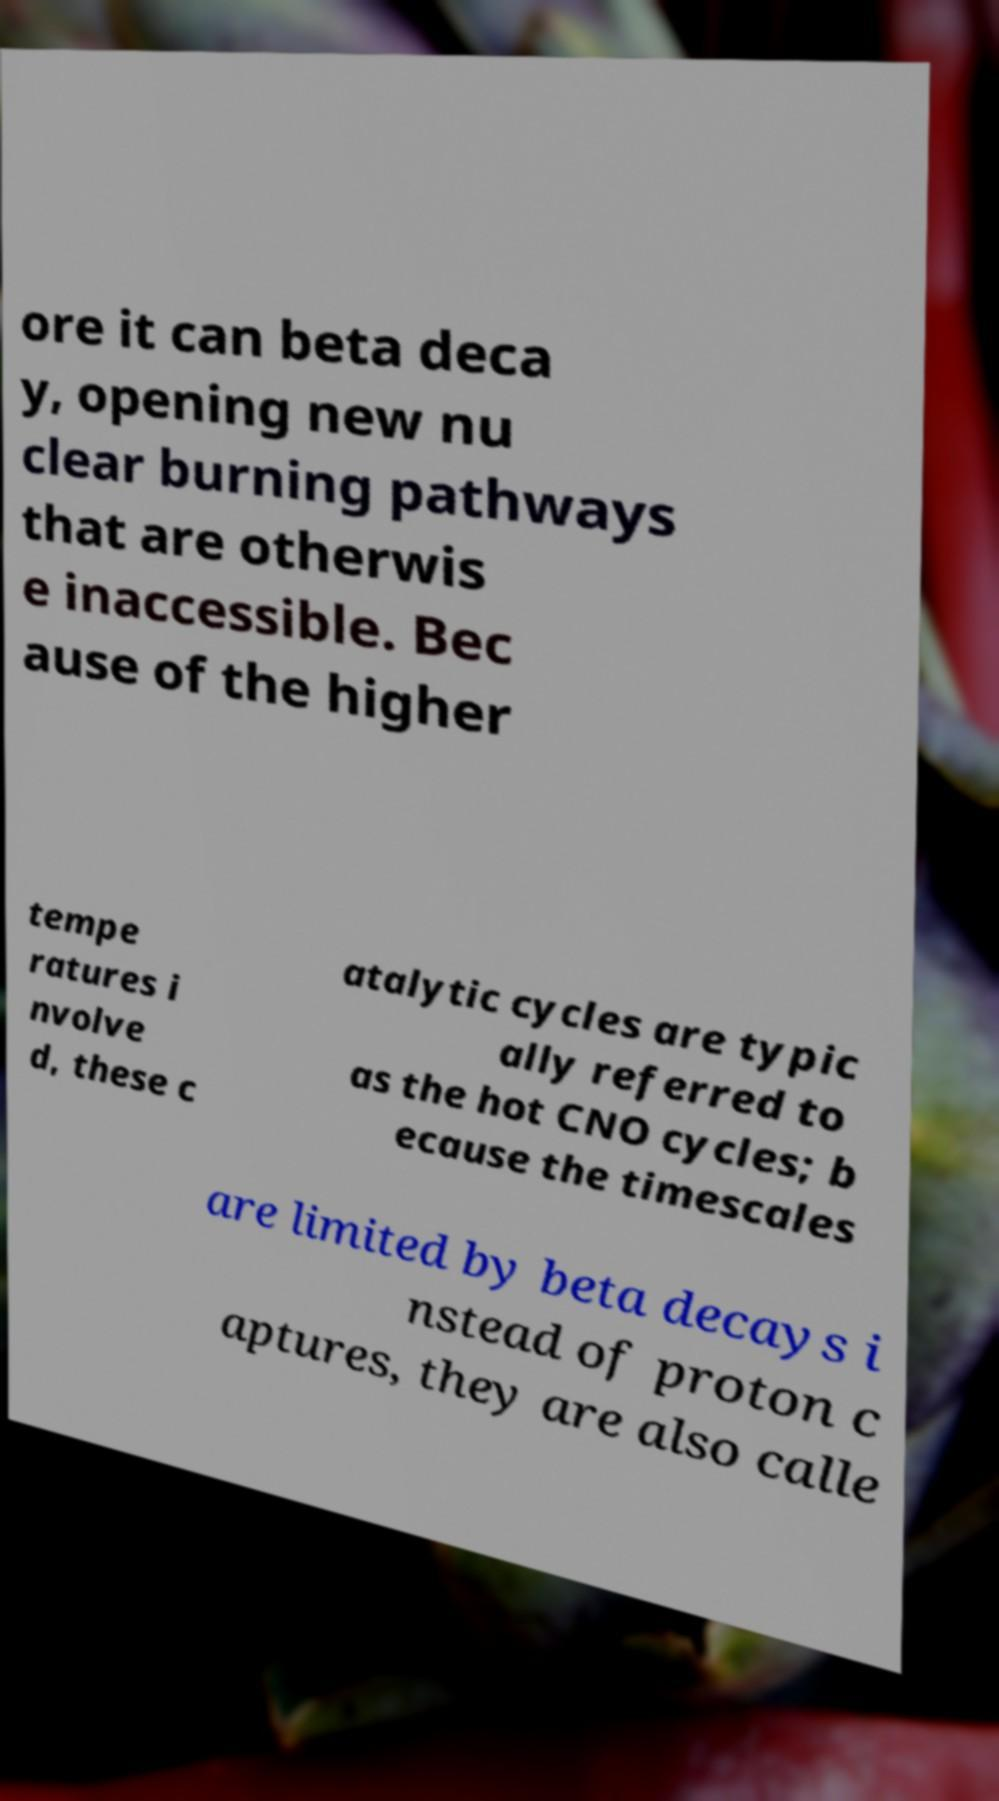Could you assist in decoding the text presented in this image and type it out clearly? ore it can beta deca y, opening new nu clear burning pathways that are otherwis e inaccessible. Bec ause of the higher tempe ratures i nvolve d, these c atalytic cycles are typic ally referred to as the hot CNO cycles; b ecause the timescales are limited by beta decays i nstead of proton c aptures, they are also calle 